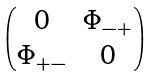Convert formula to latex. <formula><loc_0><loc_0><loc_500><loc_500>\begin{pmatrix} 0 & \Phi _ { - + } \\ \Phi _ { + - } & 0 \end{pmatrix}</formula> 